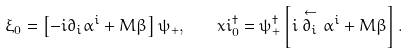Convert formula to latex. <formula><loc_0><loc_0><loc_500><loc_500>\xi _ { 0 } = \left [ - i \partial _ { i } \alpha ^ { i } + M \beta \right ] \psi _ { + } , \quad x i ^ { \dag } _ { 0 } = \psi ^ { \dag } _ { + } \left [ i \stackrel { \leftarrow } { \partial _ { i } } \alpha ^ { i } + M \beta \right ] .</formula> 